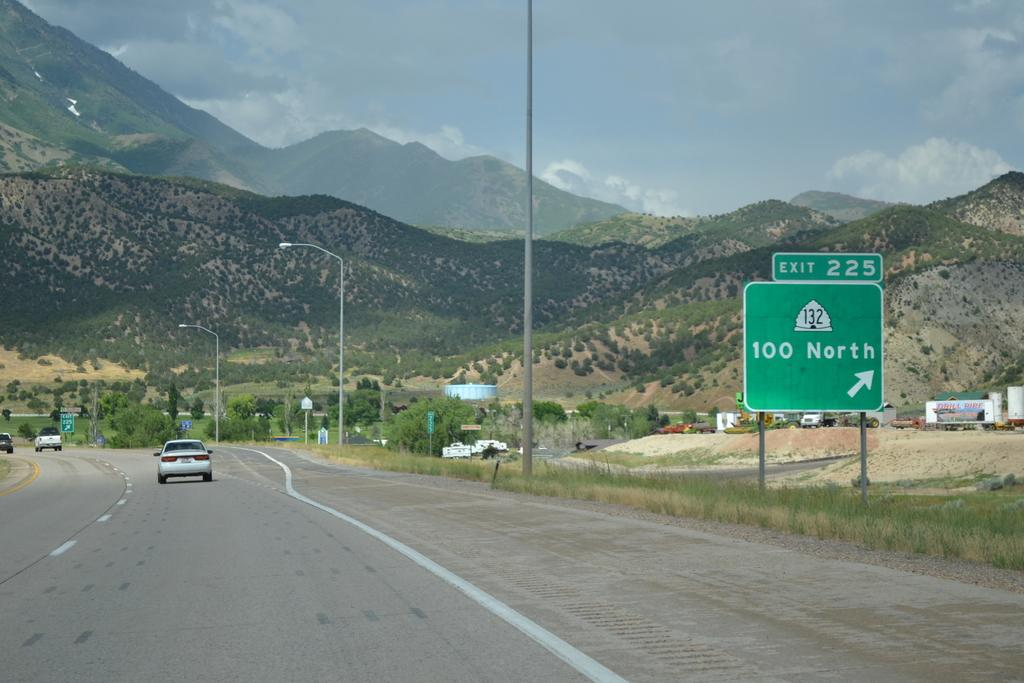<image>
Offer a succinct explanation of the picture presented. A street sign marking the Exit 225 on the right 